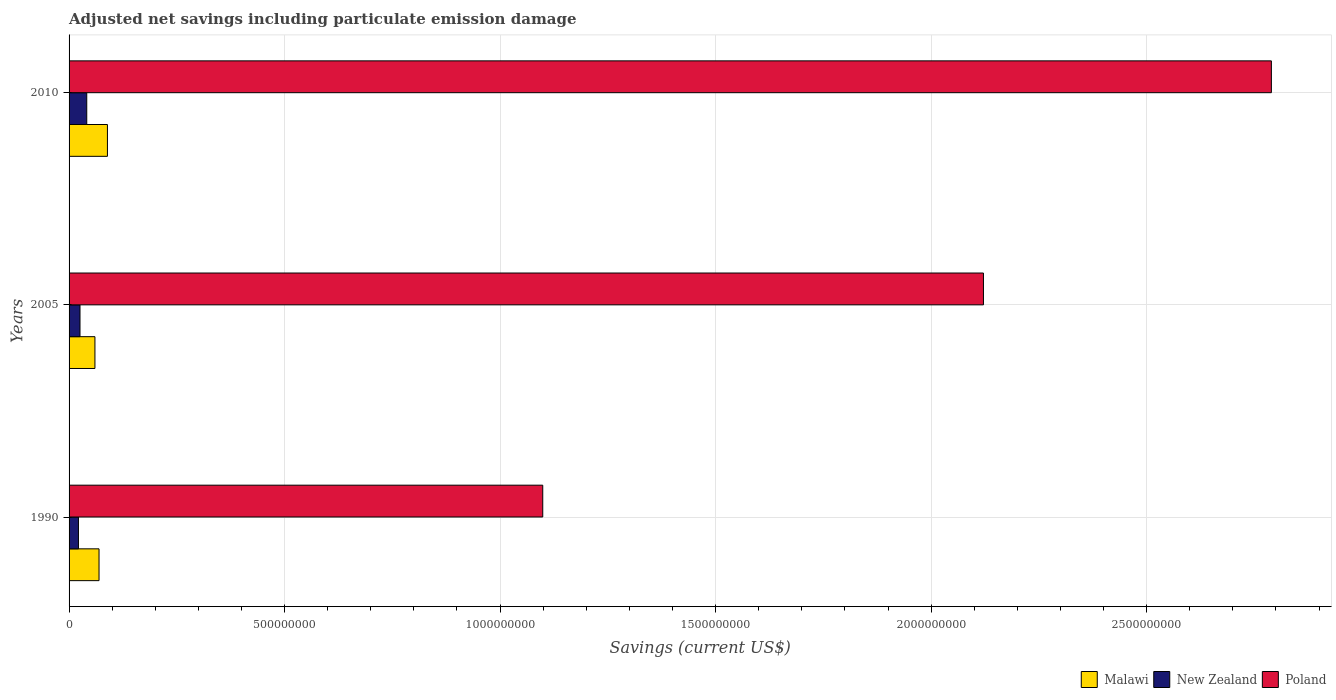Are the number of bars per tick equal to the number of legend labels?
Offer a very short reply. Yes. Are the number of bars on each tick of the Y-axis equal?
Your response must be concise. Yes. How many bars are there on the 1st tick from the bottom?
Offer a terse response. 3. What is the net savings in Malawi in 1990?
Make the answer very short. 6.95e+07. Across all years, what is the maximum net savings in New Zealand?
Ensure brevity in your answer.  4.10e+07. Across all years, what is the minimum net savings in New Zealand?
Give a very brief answer. 2.18e+07. In which year was the net savings in Poland maximum?
Offer a terse response. 2010. What is the total net savings in Malawi in the graph?
Provide a short and direct response. 2.19e+08. What is the difference between the net savings in New Zealand in 1990 and that in 2005?
Provide a succinct answer. -3.60e+06. What is the difference between the net savings in Poland in 2010 and the net savings in Malawi in 2005?
Provide a succinct answer. 2.73e+09. What is the average net savings in New Zealand per year?
Your answer should be very brief. 2.94e+07. In the year 1990, what is the difference between the net savings in Malawi and net savings in Poland?
Make the answer very short. -1.03e+09. What is the ratio of the net savings in Poland in 1990 to that in 2010?
Keep it short and to the point. 0.39. Is the net savings in Malawi in 2005 less than that in 2010?
Provide a short and direct response. Yes. What is the difference between the highest and the second highest net savings in Malawi?
Give a very brief answer. 1.95e+07. What is the difference between the highest and the lowest net savings in Malawi?
Provide a short and direct response. 2.90e+07. Is the sum of the net savings in Poland in 1990 and 2010 greater than the maximum net savings in New Zealand across all years?
Provide a short and direct response. Yes. What does the 3rd bar from the top in 1990 represents?
Make the answer very short. Malawi. What does the 2nd bar from the bottom in 2005 represents?
Your answer should be compact. New Zealand. How many bars are there?
Your answer should be very brief. 9. Are all the bars in the graph horizontal?
Your answer should be very brief. Yes. What is the difference between two consecutive major ticks on the X-axis?
Give a very brief answer. 5.00e+08. Are the values on the major ticks of X-axis written in scientific E-notation?
Provide a short and direct response. No. Does the graph contain any zero values?
Offer a terse response. No. Does the graph contain grids?
Offer a terse response. Yes. How are the legend labels stacked?
Offer a very short reply. Horizontal. What is the title of the graph?
Offer a very short reply. Adjusted net savings including particulate emission damage. Does "Iran" appear as one of the legend labels in the graph?
Offer a terse response. No. What is the label or title of the X-axis?
Keep it short and to the point. Savings (current US$). What is the label or title of the Y-axis?
Make the answer very short. Years. What is the Savings (current US$) in Malawi in 1990?
Your answer should be very brief. 6.95e+07. What is the Savings (current US$) in New Zealand in 1990?
Give a very brief answer. 2.18e+07. What is the Savings (current US$) of Poland in 1990?
Provide a short and direct response. 1.10e+09. What is the Savings (current US$) in Malawi in 2005?
Make the answer very short. 6.00e+07. What is the Savings (current US$) of New Zealand in 2005?
Provide a short and direct response. 2.54e+07. What is the Savings (current US$) in Poland in 2005?
Offer a very short reply. 2.12e+09. What is the Savings (current US$) in Malawi in 2010?
Give a very brief answer. 8.90e+07. What is the Savings (current US$) in New Zealand in 2010?
Provide a short and direct response. 4.10e+07. What is the Savings (current US$) in Poland in 2010?
Ensure brevity in your answer.  2.79e+09. Across all years, what is the maximum Savings (current US$) in Malawi?
Your answer should be compact. 8.90e+07. Across all years, what is the maximum Savings (current US$) in New Zealand?
Offer a very short reply. 4.10e+07. Across all years, what is the maximum Savings (current US$) of Poland?
Your response must be concise. 2.79e+09. Across all years, what is the minimum Savings (current US$) in Malawi?
Make the answer very short. 6.00e+07. Across all years, what is the minimum Savings (current US$) in New Zealand?
Give a very brief answer. 2.18e+07. Across all years, what is the minimum Savings (current US$) of Poland?
Offer a very short reply. 1.10e+09. What is the total Savings (current US$) of Malawi in the graph?
Ensure brevity in your answer.  2.19e+08. What is the total Savings (current US$) in New Zealand in the graph?
Give a very brief answer. 8.81e+07. What is the total Savings (current US$) in Poland in the graph?
Provide a succinct answer. 6.01e+09. What is the difference between the Savings (current US$) in Malawi in 1990 and that in 2005?
Your answer should be compact. 9.49e+06. What is the difference between the Savings (current US$) of New Zealand in 1990 and that in 2005?
Offer a terse response. -3.60e+06. What is the difference between the Savings (current US$) of Poland in 1990 and that in 2005?
Give a very brief answer. -1.02e+09. What is the difference between the Savings (current US$) of Malawi in 1990 and that in 2010?
Offer a terse response. -1.95e+07. What is the difference between the Savings (current US$) in New Zealand in 1990 and that in 2010?
Make the answer very short. -1.93e+07. What is the difference between the Savings (current US$) of Poland in 1990 and that in 2010?
Give a very brief answer. -1.69e+09. What is the difference between the Savings (current US$) of Malawi in 2005 and that in 2010?
Ensure brevity in your answer.  -2.90e+07. What is the difference between the Savings (current US$) in New Zealand in 2005 and that in 2010?
Give a very brief answer. -1.57e+07. What is the difference between the Savings (current US$) in Poland in 2005 and that in 2010?
Your answer should be compact. -6.68e+08. What is the difference between the Savings (current US$) in Malawi in 1990 and the Savings (current US$) in New Zealand in 2005?
Offer a terse response. 4.41e+07. What is the difference between the Savings (current US$) in Malawi in 1990 and the Savings (current US$) in Poland in 2005?
Make the answer very short. -2.05e+09. What is the difference between the Savings (current US$) of New Zealand in 1990 and the Savings (current US$) of Poland in 2005?
Provide a short and direct response. -2.10e+09. What is the difference between the Savings (current US$) of Malawi in 1990 and the Savings (current US$) of New Zealand in 2010?
Provide a succinct answer. 2.85e+07. What is the difference between the Savings (current US$) of Malawi in 1990 and the Savings (current US$) of Poland in 2010?
Keep it short and to the point. -2.72e+09. What is the difference between the Savings (current US$) in New Zealand in 1990 and the Savings (current US$) in Poland in 2010?
Your response must be concise. -2.77e+09. What is the difference between the Savings (current US$) in Malawi in 2005 and the Savings (current US$) in New Zealand in 2010?
Give a very brief answer. 1.90e+07. What is the difference between the Savings (current US$) of Malawi in 2005 and the Savings (current US$) of Poland in 2010?
Make the answer very short. -2.73e+09. What is the difference between the Savings (current US$) in New Zealand in 2005 and the Savings (current US$) in Poland in 2010?
Ensure brevity in your answer.  -2.76e+09. What is the average Savings (current US$) of Malawi per year?
Ensure brevity in your answer.  7.28e+07. What is the average Savings (current US$) in New Zealand per year?
Ensure brevity in your answer.  2.94e+07. What is the average Savings (current US$) in Poland per year?
Your answer should be very brief. 2.00e+09. In the year 1990, what is the difference between the Savings (current US$) of Malawi and Savings (current US$) of New Zealand?
Your answer should be compact. 4.78e+07. In the year 1990, what is the difference between the Savings (current US$) in Malawi and Savings (current US$) in Poland?
Give a very brief answer. -1.03e+09. In the year 1990, what is the difference between the Savings (current US$) of New Zealand and Savings (current US$) of Poland?
Your answer should be compact. -1.08e+09. In the year 2005, what is the difference between the Savings (current US$) in Malawi and Savings (current US$) in New Zealand?
Make the answer very short. 3.47e+07. In the year 2005, what is the difference between the Savings (current US$) in Malawi and Savings (current US$) in Poland?
Your answer should be very brief. -2.06e+09. In the year 2005, what is the difference between the Savings (current US$) of New Zealand and Savings (current US$) of Poland?
Offer a terse response. -2.10e+09. In the year 2010, what is the difference between the Savings (current US$) in Malawi and Savings (current US$) in New Zealand?
Give a very brief answer. 4.80e+07. In the year 2010, what is the difference between the Savings (current US$) in Malawi and Savings (current US$) in Poland?
Your response must be concise. -2.70e+09. In the year 2010, what is the difference between the Savings (current US$) of New Zealand and Savings (current US$) of Poland?
Make the answer very short. -2.75e+09. What is the ratio of the Savings (current US$) in Malawi in 1990 to that in 2005?
Give a very brief answer. 1.16. What is the ratio of the Savings (current US$) of New Zealand in 1990 to that in 2005?
Keep it short and to the point. 0.86. What is the ratio of the Savings (current US$) of Poland in 1990 to that in 2005?
Provide a short and direct response. 0.52. What is the ratio of the Savings (current US$) of Malawi in 1990 to that in 2010?
Ensure brevity in your answer.  0.78. What is the ratio of the Savings (current US$) in New Zealand in 1990 to that in 2010?
Your response must be concise. 0.53. What is the ratio of the Savings (current US$) in Poland in 1990 to that in 2010?
Offer a very short reply. 0.39. What is the ratio of the Savings (current US$) in Malawi in 2005 to that in 2010?
Provide a succinct answer. 0.67. What is the ratio of the Savings (current US$) in New Zealand in 2005 to that in 2010?
Offer a terse response. 0.62. What is the ratio of the Savings (current US$) of Poland in 2005 to that in 2010?
Provide a succinct answer. 0.76. What is the difference between the highest and the second highest Savings (current US$) of Malawi?
Offer a terse response. 1.95e+07. What is the difference between the highest and the second highest Savings (current US$) of New Zealand?
Ensure brevity in your answer.  1.57e+07. What is the difference between the highest and the second highest Savings (current US$) in Poland?
Make the answer very short. 6.68e+08. What is the difference between the highest and the lowest Savings (current US$) in Malawi?
Provide a succinct answer. 2.90e+07. What is the difference between the highest and the lowest Savings (current US$) of New Zealand?
Your answer should be compact. 1.93e+07. What is the difference between the highest and the lowest Savings (current US$) in Poland?
Provide a succinct answer. 1.69e+09. 